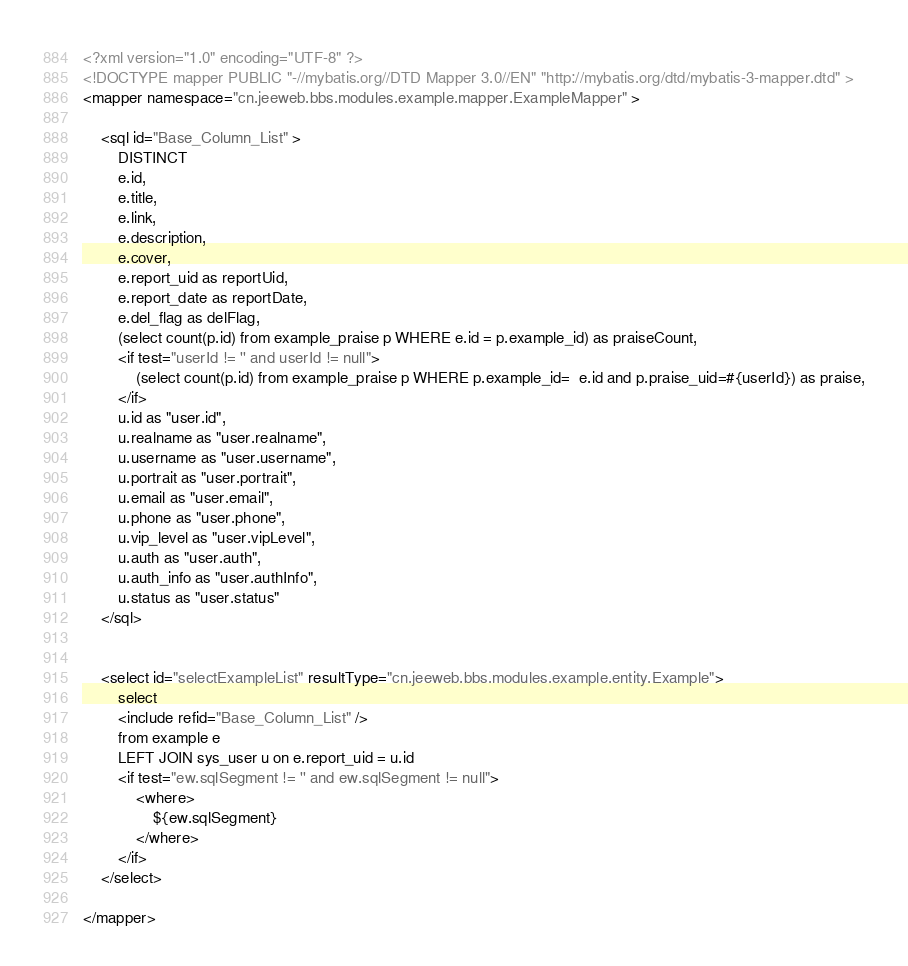Convert code to text. <code><loc_0><loc_0><loc_500><loc_500><_XML_><?xml version="1.0" encoding="UTF-8" ?>
<!DOCTYPE mapper PUBLIC "-//mybatis.org//DTD Mapper 3.0//EN" "http://mybatis.org/dtd/mybatis-3-mapper.dtd" >
<mapper namespace="cn.jeeweb.bbs.modules.example.mapper.ExampleMapper" >

    <sql id="Base_Column_List" >
        DISTINCT
        e.id,
        e.title,
        e.link,
        e.description,
        e.cover,
        e.report_uid as reportUid,
        e.report_date as reportDate,
        e.del_flag as delFlag,
        (select count(p.id) from example_praise p WHERE e.id = p.example_id) as praiseCount,
        <if test="userId != '' and userId != null">
            (select count(p.id) from example_praise p WHERE p.example_id=  e.id and p.praise_uid=#{userId}) as praise,
        </if>
        u.id as "user.id",
        u.realname as "user.realname",
        u.username as "user.username",
        u.portrait as "user.portrait",
        u.email as "user.email",
        u.phone as "user.phone",
        u.vip_level as "user.vipLevel",
        u.auth as "user.auth",
        u.auth_info as "user.authInfo",
        u.status as "user.status"
    </sql>


    <select id="selectExampleList" resultType="cn.jeeweb.bbs.modules.example.entity.Example">
        select
        <include refid="Base_Column_List" />
        from example e
        LEFT JOIN sys_user u on e.report_uid = u.id
        <if test="ew.sqlSegment != '' and ew.sqlSegment != null">
            <where>
                ${ew.sqlSegment}
            </where>
        </if>
    </select>

</mapper></code> 